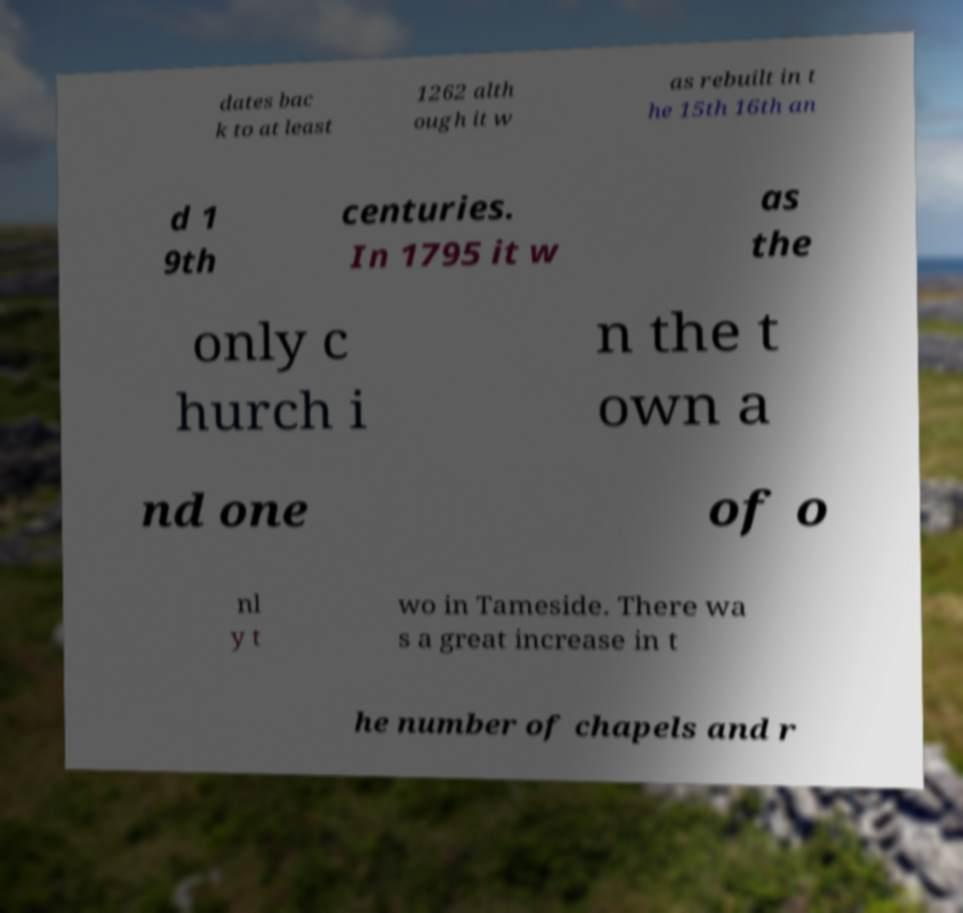There's text embedded in this image that I need extracted. Can you transcribe it verbatim? dates bac k to at least 1262 alth ough it w as rebuilt in t he 15th 16th an d 1 9th centuries. In 1795 it w as the only c hurch i n the t own a nd one of o nl y t wo in Tameside. There wa s a great increase in t he number of chapels and r 